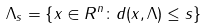<formula> <loc_0><loc_0><loc_500><loc_500>\Lambda _ { s } = \left \{ x \in R ^ { n } \colon d ( x , \Lambda ) \leq s \right \}</formula> 